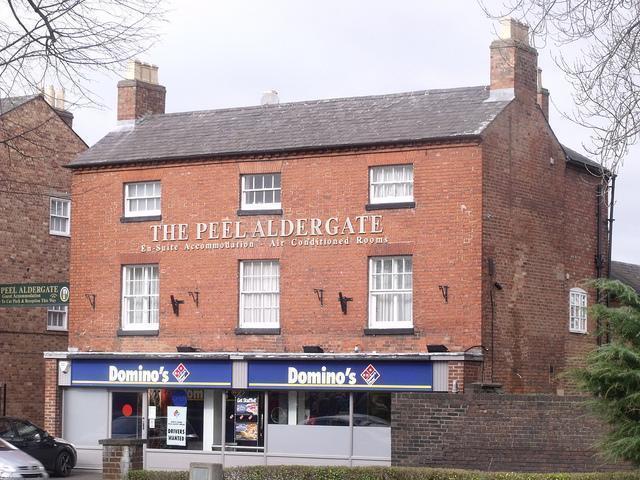What pizza place is on the main level?
Choose the right answer and clarify with the format: 'Answer: answer
Rationale: rationale.'
Options: Little caesars, pizza hut, papa john's, domino's. Answer: domino's.
Rationale: The store front lowest to the ground in this scene read's domino's. domino's is known as a pizza restaurant. 